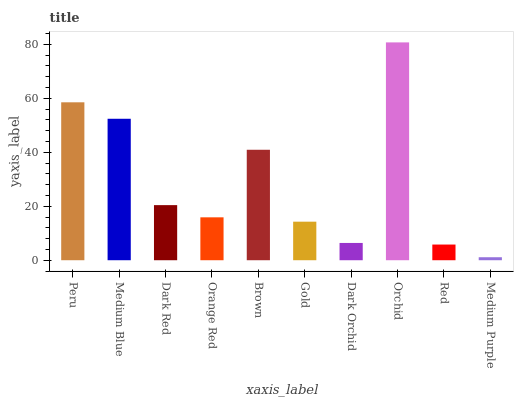Is Medium Purple the minimum?
Answer yes or no. Yes. Is Orchid the maximum?
Answer yes or no. Yes. Is Medium Blue the minimum?
Answer yes or no. No. Is Medium Blue the maximum?
Answer yes or no. No. Is Peru greater than Medium Blue?
Answer yes or no. Yes. Is Medium Blue less than Peru?
Answer yes or no. Yes. Is Medium Blue greater than Peru?
Answer yes or no. No. Is Peru less than Medium Blue?
Answer yes or no. No. Is Dark Red the high median?
Answer yes or no. Yes. Is Orange Red the low median?
Answer yes or no. Yes. Is Gold the high median?
Answer yes or no. No. Is Medium Purple the low median?
Answer yes or no. No. 